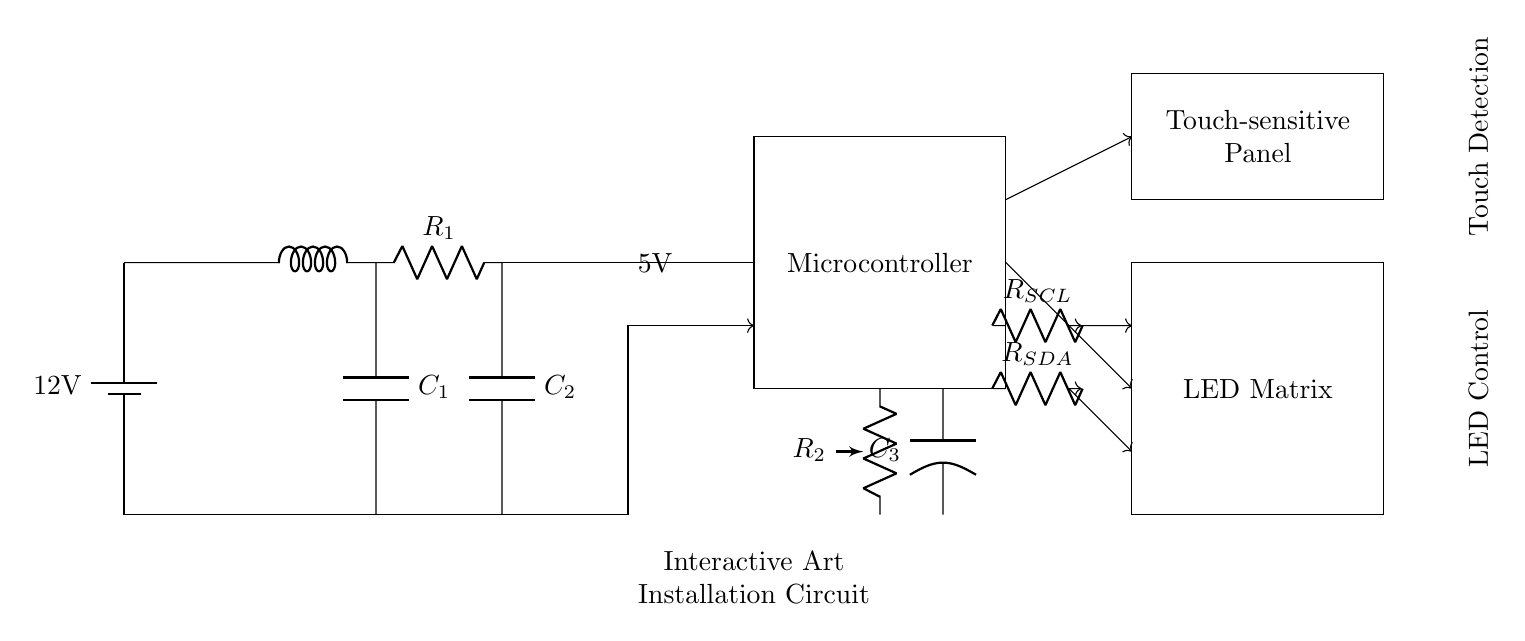What is the main power supply voltage? The main power supply voltage is indicated by the battery symbol at the top of the circuit diagram, which shows a voltage of 12 volts.
Answer: 12 volts What component regulates the voltage in this circuit? The voltage regulator is represented by the cute inductor that is directly connected after the battery. Its function is to ensure that the voltage is appropriately altered before being sent to other components.
Answer: Inductor What device does the microcontroller connect to for touch detection? The microcontroller connects to the touch-sensitive panel, which is shown in the circuit diagram above the microcontroller, via an upward arrow indicating the direction of connection.
Answer: Touch-sensitive panel What type of connection is used for I2C communication in this circuit? The I2C communication is represented by two arrows for both SCL and SDA, indicating bidirectional channels for data transfer between the microcontroller and the LED matrix. This type of connection allows for synchronous communication.
Answer: Bidirectional How many capacitors are present in the circuit? The circuit diagram displays two distinct capacitors, labeled as C1 and C2, connected at different points within the circuit. Each is represented by a capacitor symbol in the diagram.
Answer: Two What is the role of resistors R_SCL and R_SDA in this circuit? Resistors R_SCL and R_SDA are connected in line with the respective signals for the SCL (serial clock line) and SDA (serial data line) for the I2C communication. Their function is to limit the current and ensure the signals are stable during communication, which is crucial for proper operation.
Answer: Limit current and stabilize signals 